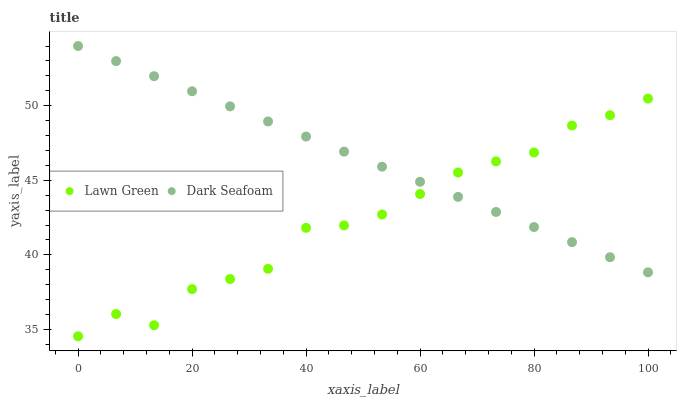Does Lawn Green have the minimum area under the curve?
Answer yes or no. Yes. Does Dark Seafoam have the maximum area under the curve?
Answer yes or no. Yes. Does Dark Seafoam have the minimum area under the curve?
Answer yes or no. No. Is Dark Seafoam the smoothest?
Answer yes or no. Yes. Is Lawn Green the roughest?
Answer yes or no. Yes. Is Dark Seafoam the roughest?
Answer yes or no. No. Does Lawn Green have the lowest value?
Answer yes or no. Yes. Does Dark Seafoam have the lowest value?
Answer yes or no. No. Does Dark Seafoam have the highest value?
Answer yes or no. Yes. Does Lawn Green intersect Dark Seafoam?
Answer yes or no. Yes. Is Lawn Green less than Dark Seafoam?
Answer yes or no. No. Is Lawn Green greater than Dark Seafoam?
Answer yes or no. No. 